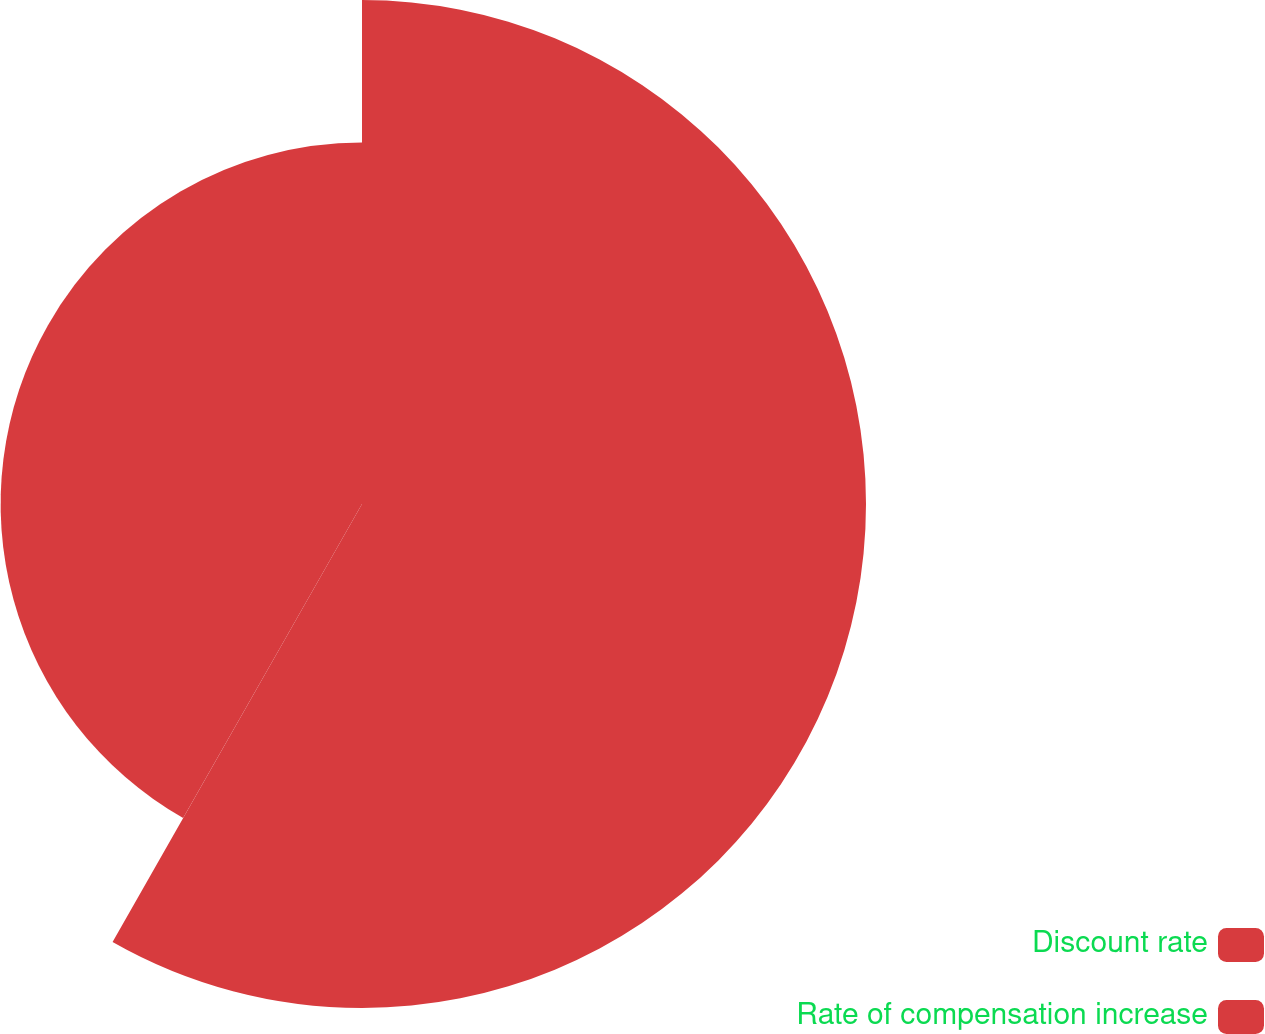Convert chart to OTSL. <chart><loc_0><loc_0><loc_500><loc_500><pie_chart><fcel>Discount rate<fcel>Rate of compensation increase<nl><fcel>58.24%<fcel>41.76%<nl></chart> 